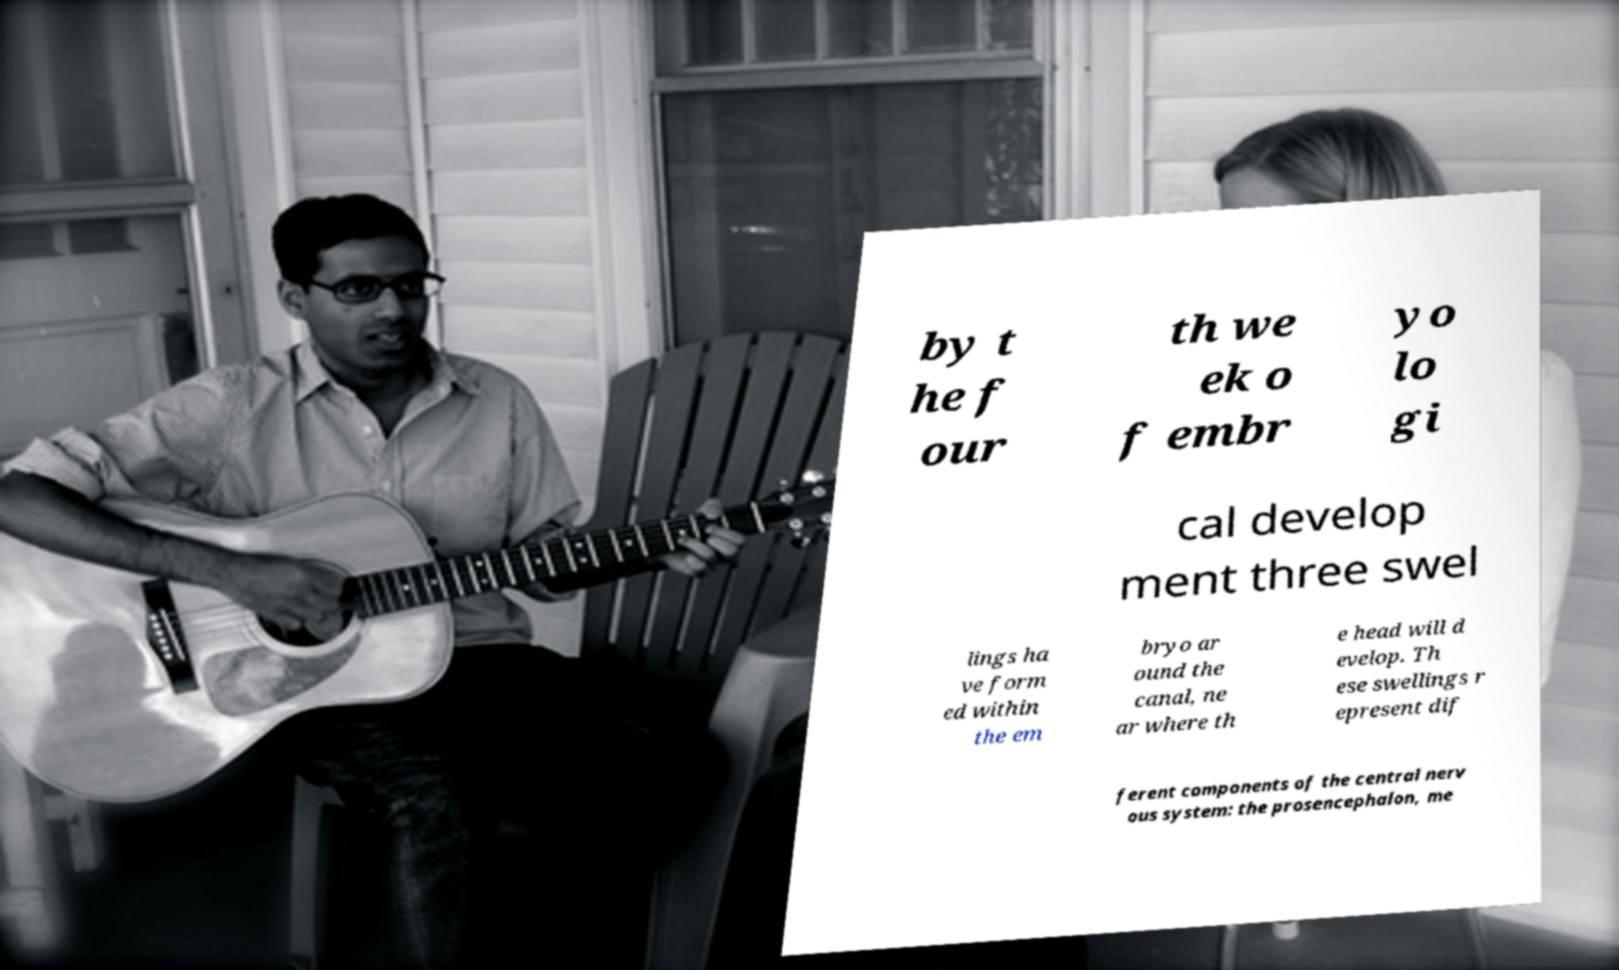There's text embedded in this image that I need extracted. Can you transcribe it verbatim? by t he f our th we ek o f embr yo lo gi cal develop ment three swel lings ha ve form ed within the em bryo ar ound the canal, ne ar where th e head will d evelop. Th ese swellings r epresent dif ferent components of the central nerv ous system: the prosencephalon, me 